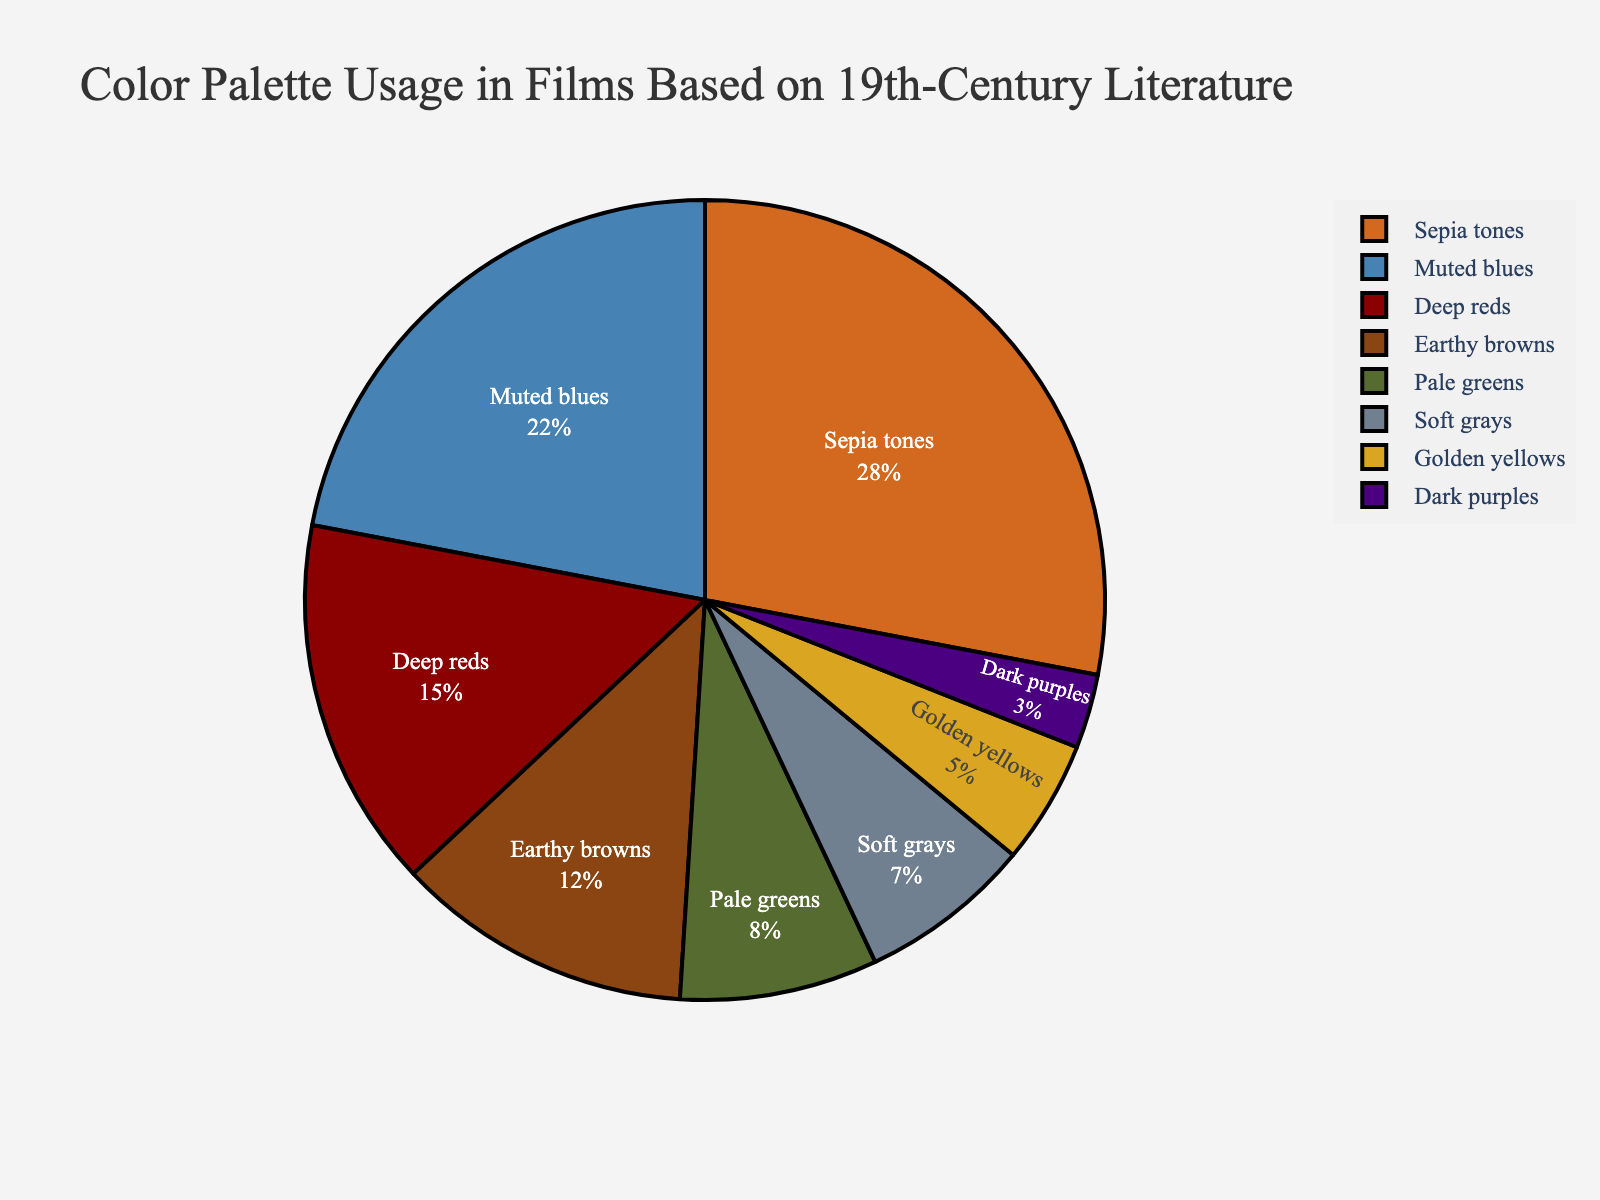What proportion of the color palette is used by 'Sepia tones' and 'Deep reds' combined? Add the percentages for 'Sepia tones' (28%) and 'Deep reds' (15%). The sum is 28 + 15 = 43.
Answer: 43% Which color has the least usage proportion? Look for the color with the smallest percentage. 'Dark purples' has the smallest proportion with 3%.
Answer: Dark purples How much more is the proportion of 'Muted blues' than 'Soft grays'? Subtract the percentage of 'Soft grays' (7%) from 'Muted blues' (22%). The difference is 22 - 7 = 15.
Answer: 15% Which colors constitute more than 50% of the total usage together? Add the percentages of each color in descending order until the sum exceeds 50%. 'Sepia tones' (28%), 'Muted blues' (22%), together make 28 + 22 = 50%. Since 50% is inclusive, they exceed 50% together.
Answer: Sepia tones, Muted blues How many colors have a proportion of less than 10%? Count the colors with percentages less than 10%: 'Pale greens' (8%), 'Soft grays' (7%), 'Golden yellows' (5%), and 'Dark purples' (3%). There are 4 such colors.
Answer: 4 Which color has the third highest proportion? Arrange the colors by descending percentage and identify the third one. The first is 'Sepia tones' (28%), the second is 'Muted blues' (22%), and the third is 'Deep reds' (15%).
Answer: Deep reds What's the average proportion of 'Earthy browns,' 'Golden yellows,' and 'Dark purples'? Add the percentages for 'Earthy browns' (12%), 'Golden yellows' (5%), and 'Dark purples' (3%). Then, divide by 3: (12 + 5 + 3)/3 = 20/3 ≈ 6.67.
Answer: 6.67% Which two colors have a combined usage of exactly 20%? Check pairs of percentages to find a sum of 20%. 'Pale greens' (8%) and 'Soft grays' (7%) together constitute (8 + 7 = 15), 'Soft grays' and 'Golden yellows' constitute (7 + 5 = 12), 'Golden yellows' and 'Dark purples' together constitute (5 + 3 = 8). Finally, 'Deep reds' (15%) and 'Earthy browns' (12%) don't sum to 20%. Sorry, there are no pairs summing to exactly 20%.
Answer: None 